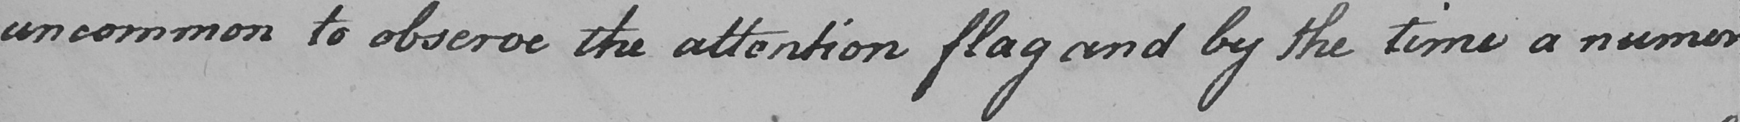Can you tell me what this handwritten text says? uncommon to observe the attention flag and by the time a numer 